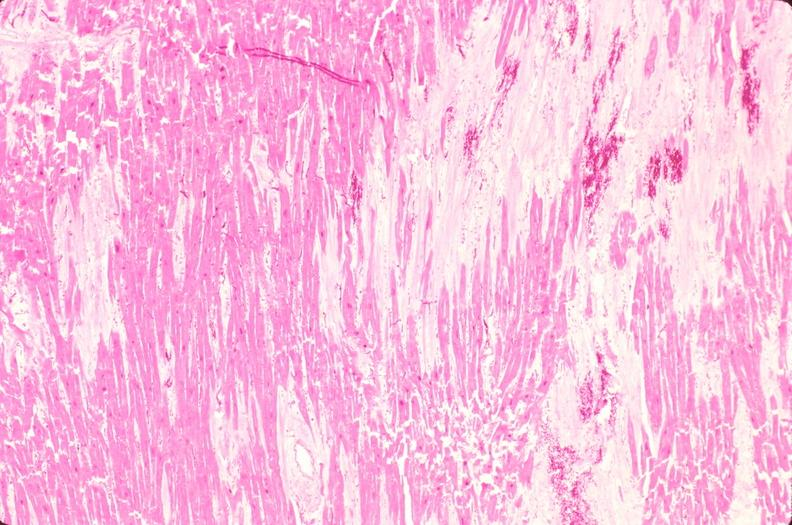does this image show heart, old myocardial infarction with fibrosis, he?
Answer the question using a single word or phrase. Yes 